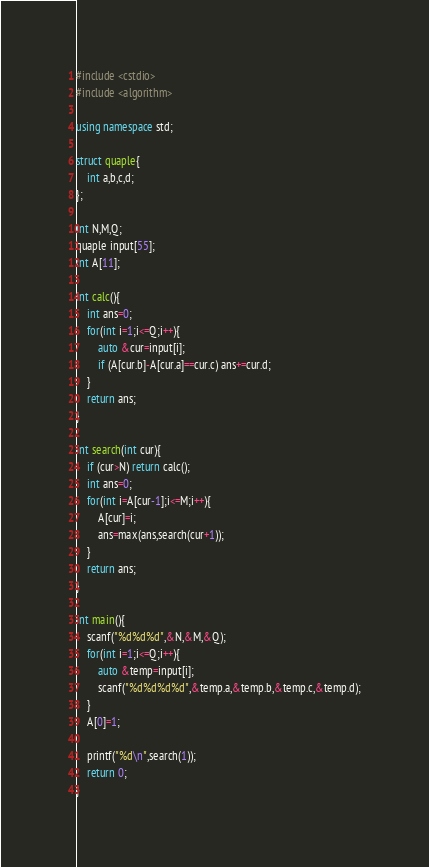<code> <loc_0><loc_0><loc_500><loc_500><_C++_>#include <cstdio>
#include <algorithm>

using namespace std;

struct quaple{
    int a,b,c,d;
};

int N,M,Q;
quaple input[55];
int A[11];

int calc(){
    int ans=0;
    for(int i=1;i<=Q;i++){
        auto &cur=input[i];
        if (A[cur.b]-A[cur.a]==cur.c) ans+=cur.d;
    }
    return ans;
}

int search(int cur){
    if (cur>N) return calc();
    int ans=0;
    for(int i=A[cur-1];i<=M;i++){
        A[cur]=i;
        ans=max(ans,search(cur+1));
    }
    return ans;
}

int main(){
    scanf("%d%d%d",&N,&M,&Q);
    for(int i=1;i<=Q;i++){
        auto &temp=input[i];
        scanf("%d%d%d%d",&temp.a,&temp.b,&temp.c,&temp.d);
    }
    A[0]=1;

    printf("%d\n",search(1));
    return 0;
}</code> 